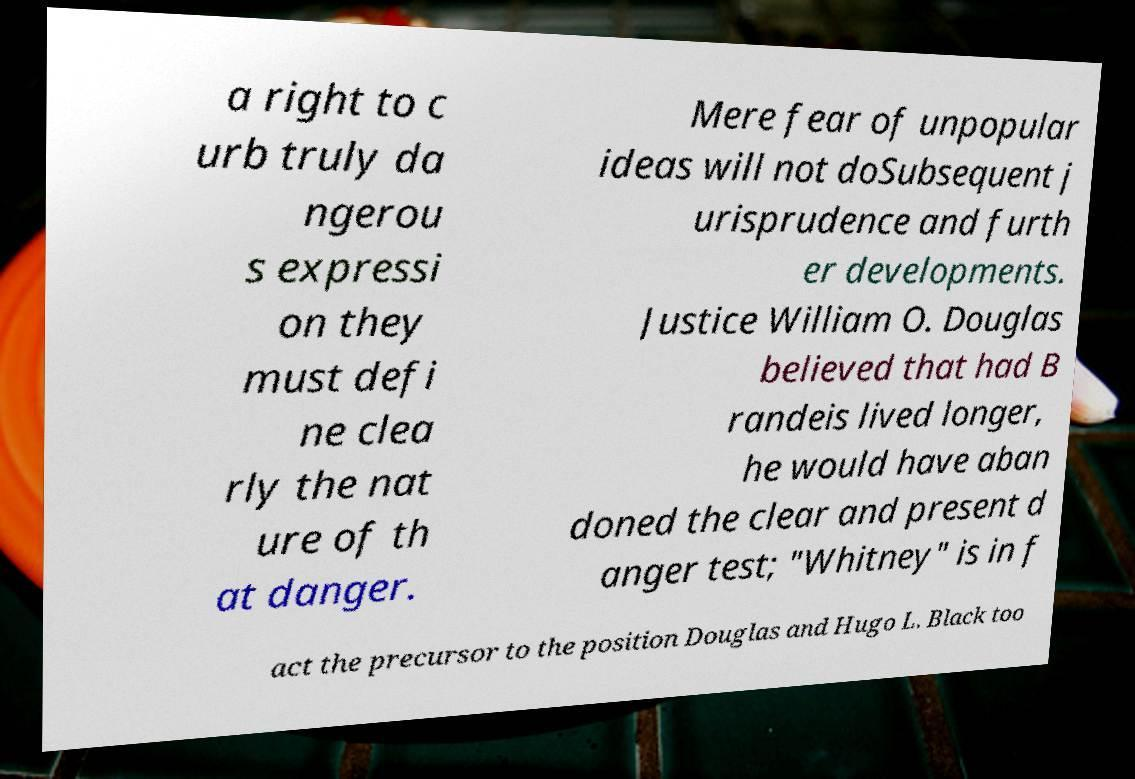I need the written content from this picture converted into text. Can you do that? a right to c urb truly da ngerou s expressi on they must defi ne clea rly the nat ure of th at danger. Mere fear of unpopular ideas will not doSubsequent j urisprudence and furth er developments. Justice William O. Douglas believed that had B randeis lived longer, he would have aban doned the clear and present d anger test; "Whitney" is in f act the precursor to the position Douglas and Hugo L. Black too 